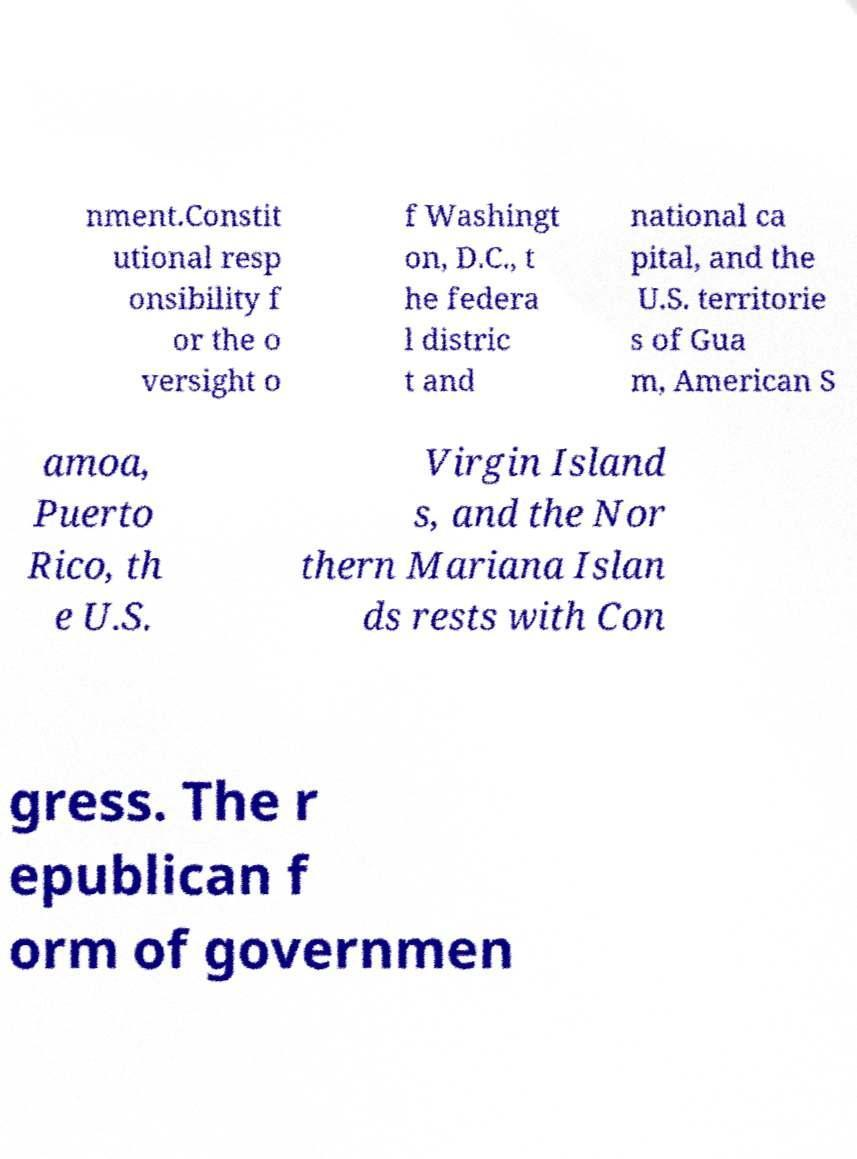Can you accurately transcribe the text from the provided image for me? nment.Constit utional resp onsibility f or the o versight o f Washingt on, D.C., t he federa l distric t and national ca pital, and the U.S. territorie s of Gua m, American S amoa, Puerto Rico, th e U.S. Virgin Island s, and the Nor thern Mariana Islan ds rests with Con gress. The r epublican f orm of governmen 